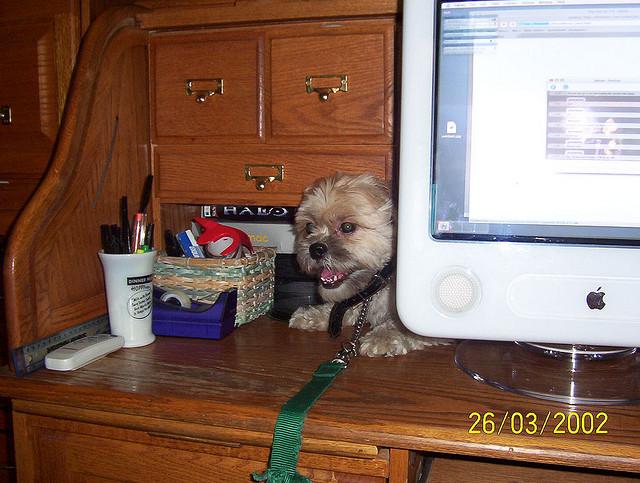What model of computer is on the table?
Keep it brief. Apple. What is that green thing laying on desk?
Give a very brief answer. Leash. How many remote controls are in the photo?
Be succinct. 1. Is the little dog wearing a necktie?
Quick response, please. No. 